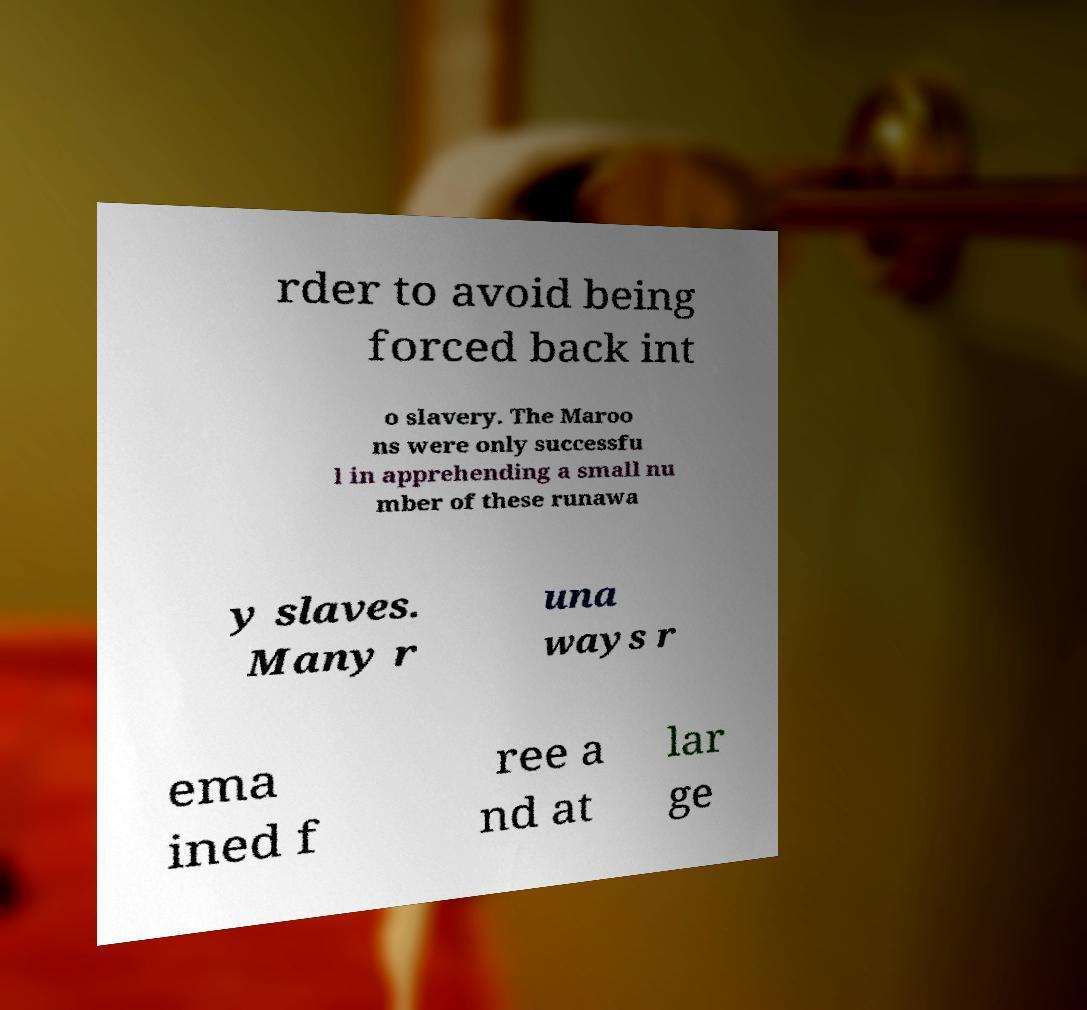What messages or text are displayed in this image? I need them in a readable, typed format. rder to avoid being forced back int o slavery. The Maroo ns were only successfu l in apprehending a small nu mber of these runawa y slaves. Many r una ways r ema ined f ree a nd at lar ge 